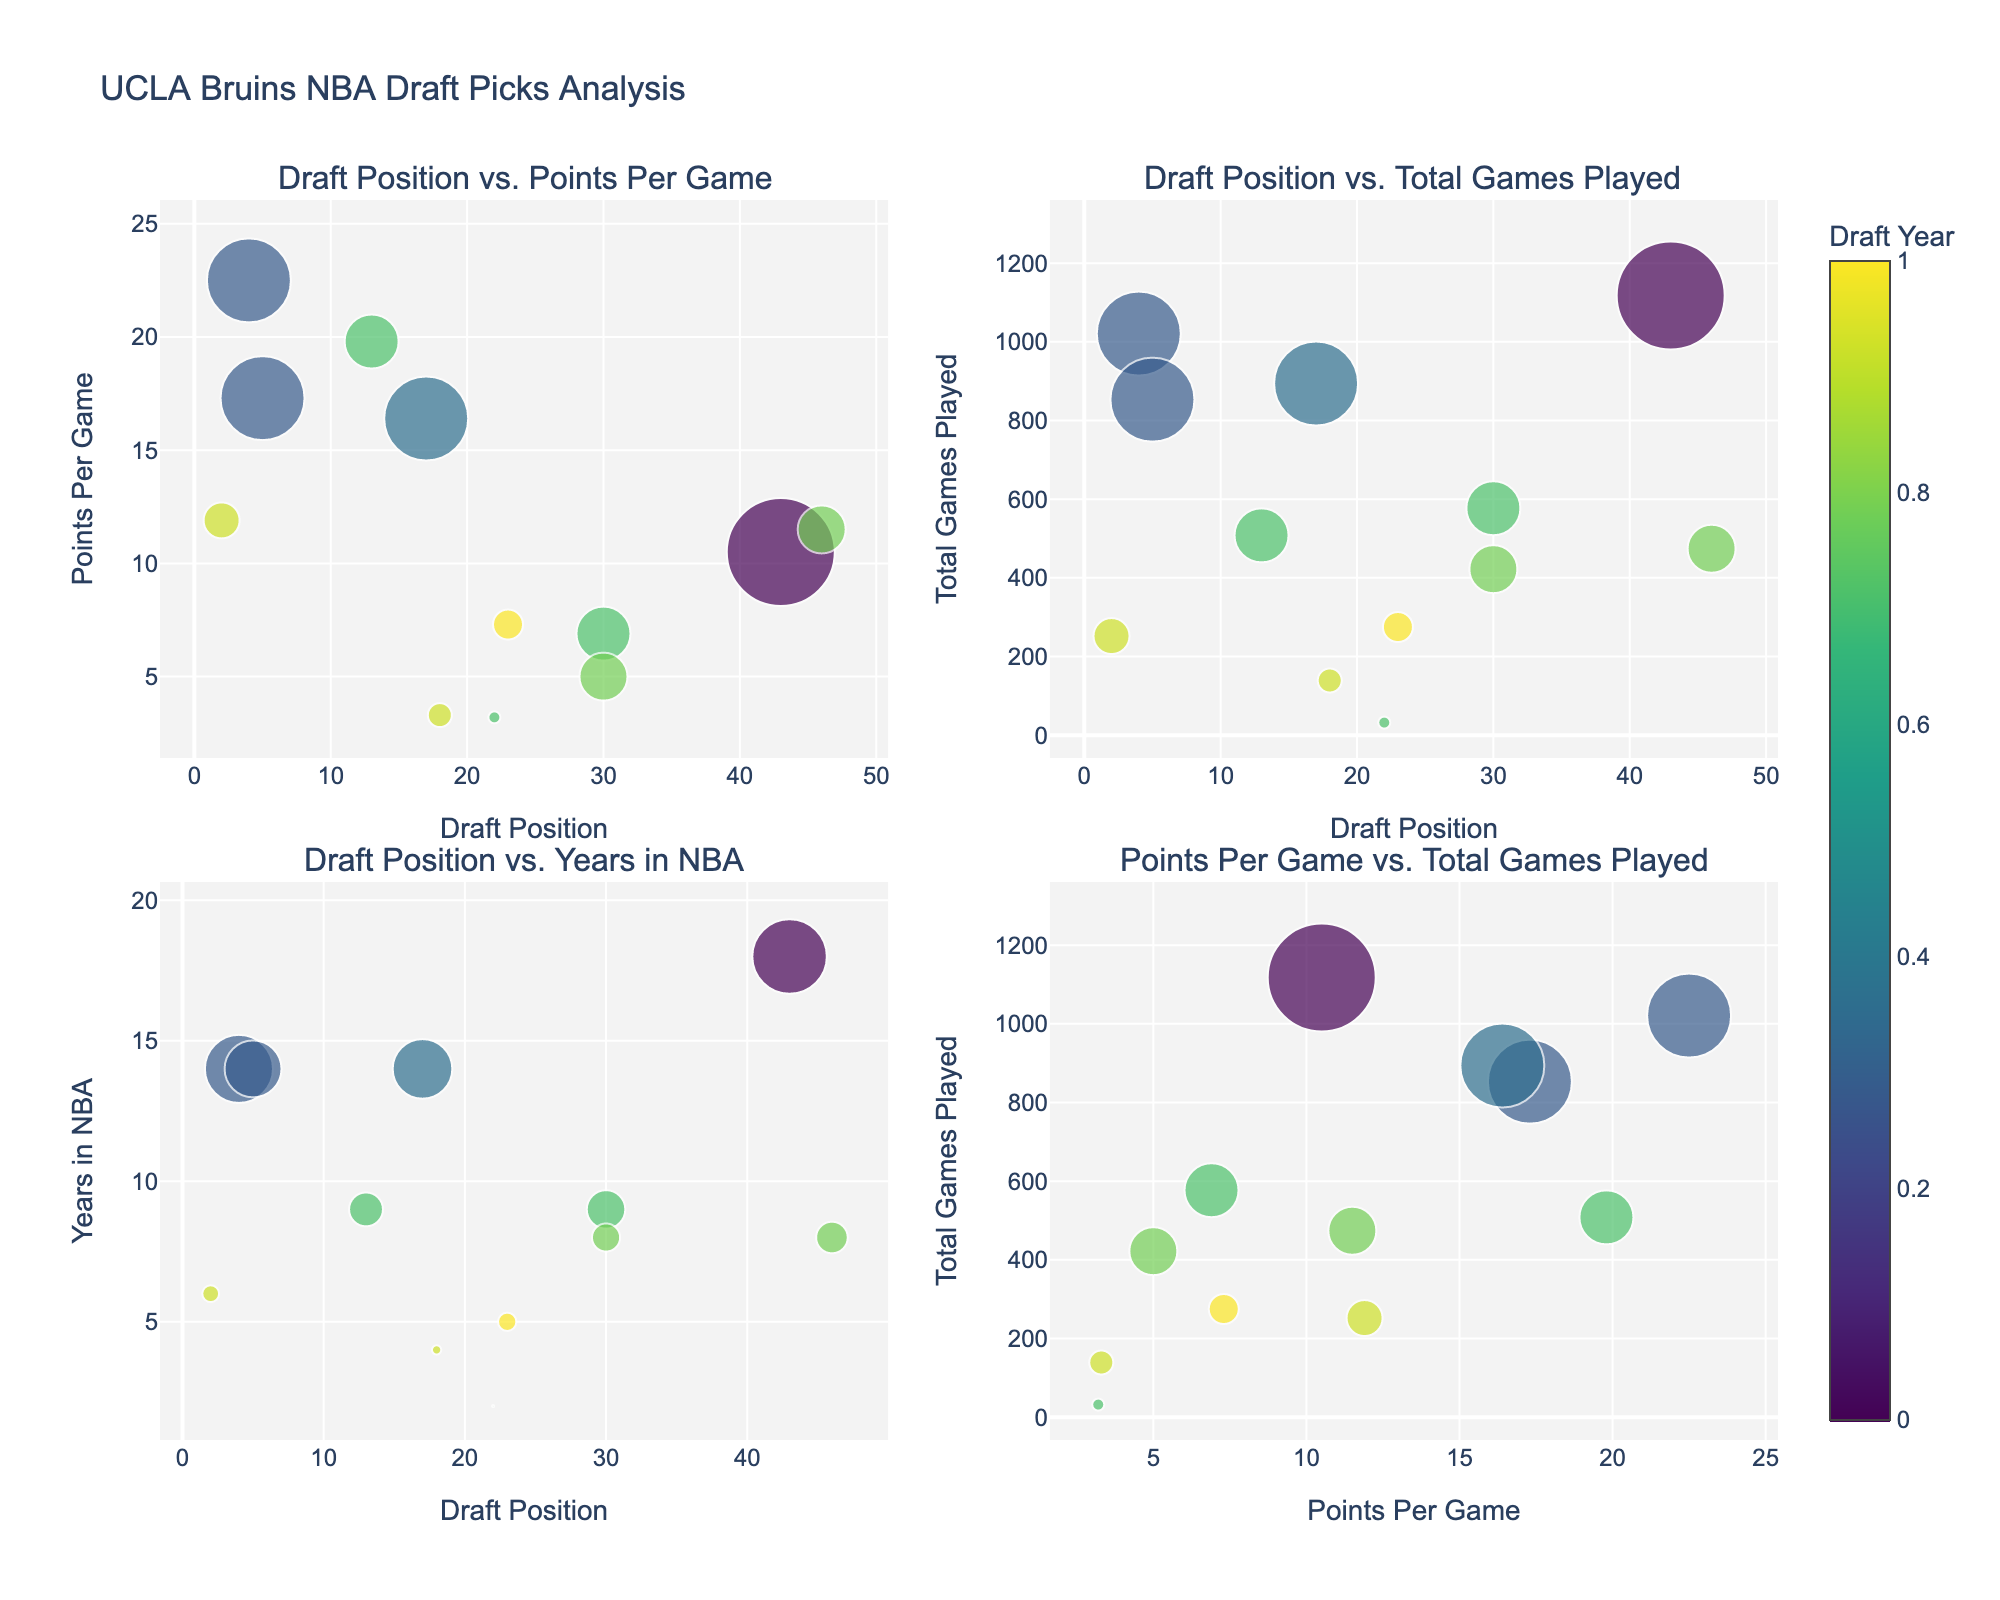What's the title of the figure? The title of the figure is shown at the top center of the visual. It reads "UCLA Bruins NBA Draft Picks Analysis".
Answer: UCLA Bruins NBA Draft Picks Analysis How many subplots are there in the figure? The figure is divided into four separate plots, arranged in a 2x2 grid.
Answer: Four Which player has the highest Points Per Game (PPG) and what is his PPG? In the subplot "Draft Position vs. Points Per Game", look for the highest vertical point. The label shows it's Russell Westbrook with a PPG of 22.5.
Answer: Russell Westbrook, 22.5 Who is the player with the most NBA seasons, and how many seasons has he played? In the subplot "Draft Position vs. Years in NBA", look for the tallest bubble. Trevor Ariza has played the most seasons with 18 years in the NBA.
Answer: Trevor Ariza, 18 What is the draft position and PPG of the player with the most NBA seasons? By checking the marker for Trevor Ariza in the "Draft Position vs. Years in NBA" plot, correlate with the "Draft Position vs. Points Per Game" plot. He was drafted at position 43 and has a PPG of 10.5.
Answer: 43, 10.5 What are the positions and total games played for the players drafted in 2014? By identifying the colors in the "Draft Position vs. Total Games Played" and cross-referencing with the draft year: Zach LaVine was drafted 13th with 508 games, Jordan Adams was drafted 22nd with 32 games, and Kyle Anderson was drafted 30th with 577 games.
Answer: 13/508, 22/32, 30/577 Which player has the least PPG and how many games has he played? In the subplot "Draft Position vs. Points Per Game", identify the lowest vertical point. It's Jordan Adams with a PPG of 3.2. Checking "Draft Position vs. Total Games Played", he has played 32 games.
Answer: Jordan Adams, 32 Which two players were drafted closest to one another in position, and what are their corresponding PPGs? In the "Draft Position vs. Points Per Game" subplot, Aaron Holiday and T.J. Leaf were drafted 23rd and 18th respectively. Aaron Holiday has a PPG of 7.3 and T.J. Leaf has a PPG of 3.3.
Answer: Aaron Holiday (7.3), T.J. Leaf (3.3) Which subplot shows the relationship between PPG and total games played? The subplot "Points Per Game vs. Total Games Played" is the one that depicts this relationship and is located at the bottom right corner of the figure.
Answer: Points Per Game vs. Total Games Played 